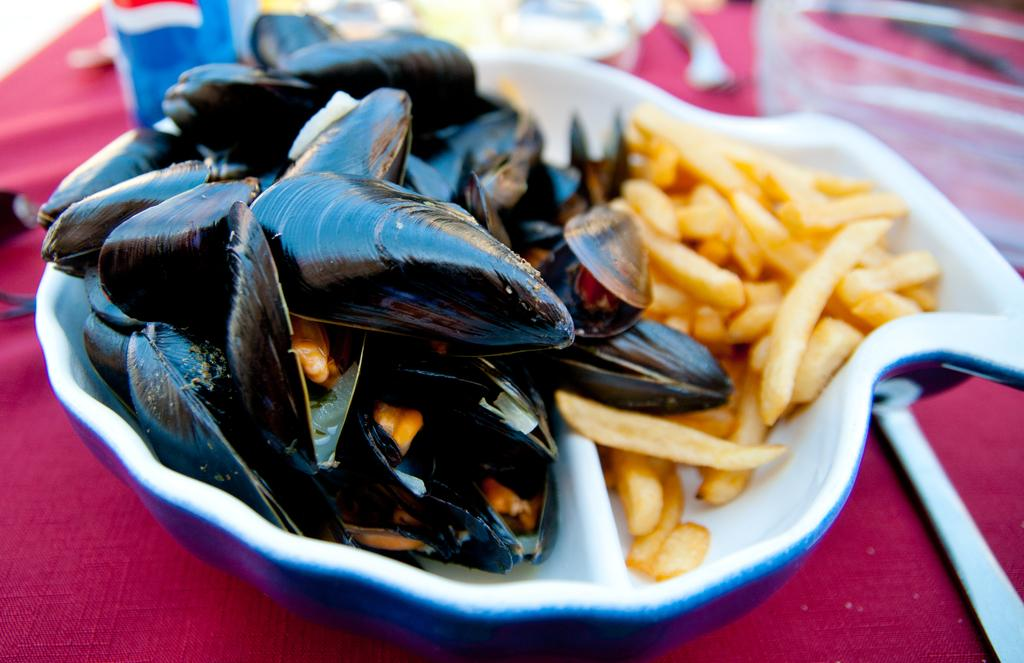What type of food can be seen in the image? There is sea food in the image. What other type of food is present in the image? There are french fries in a bowl in the image. What type of containers are visible in the image? There are glasses and a bowl in the image. What other object can be seen in the image? There is a bottle in the image. Where might these objects be placed? The objects are likely on a table. Can you make any assumptions about the location based on the image? The image might have been taken in a hotel. What is the current tax rate for the seafood in the image? There is no information about tax rates in the image, as it focuses on the food and objects present. 